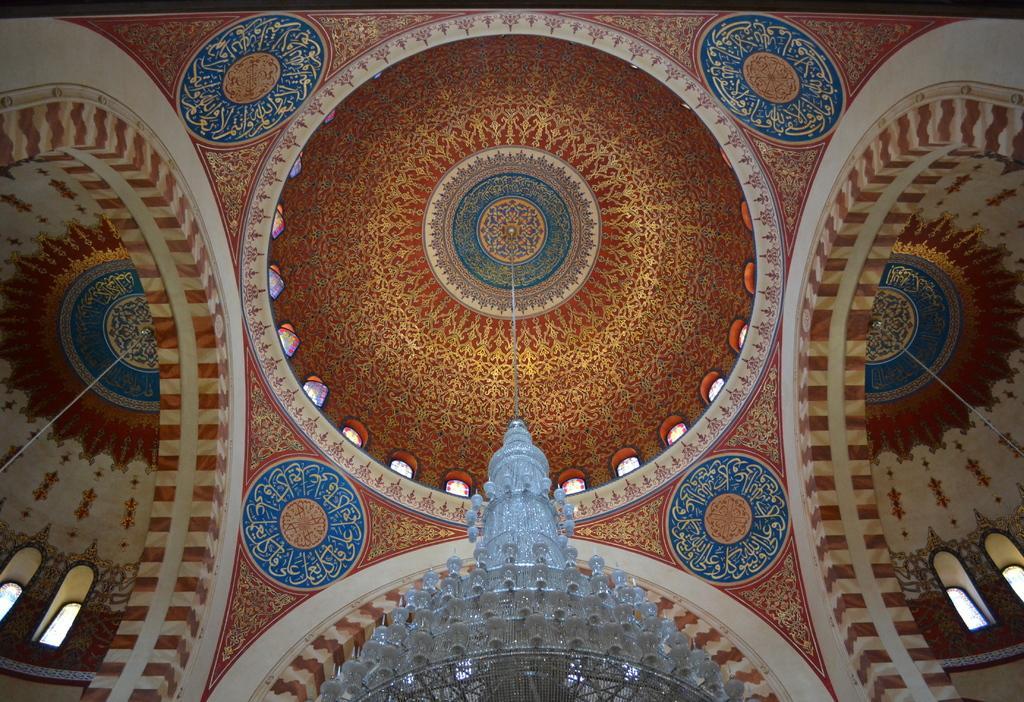Please provide a concise description of this image. In this image we can see light hanging from the roof. In the background we can see ceiling and windows. 